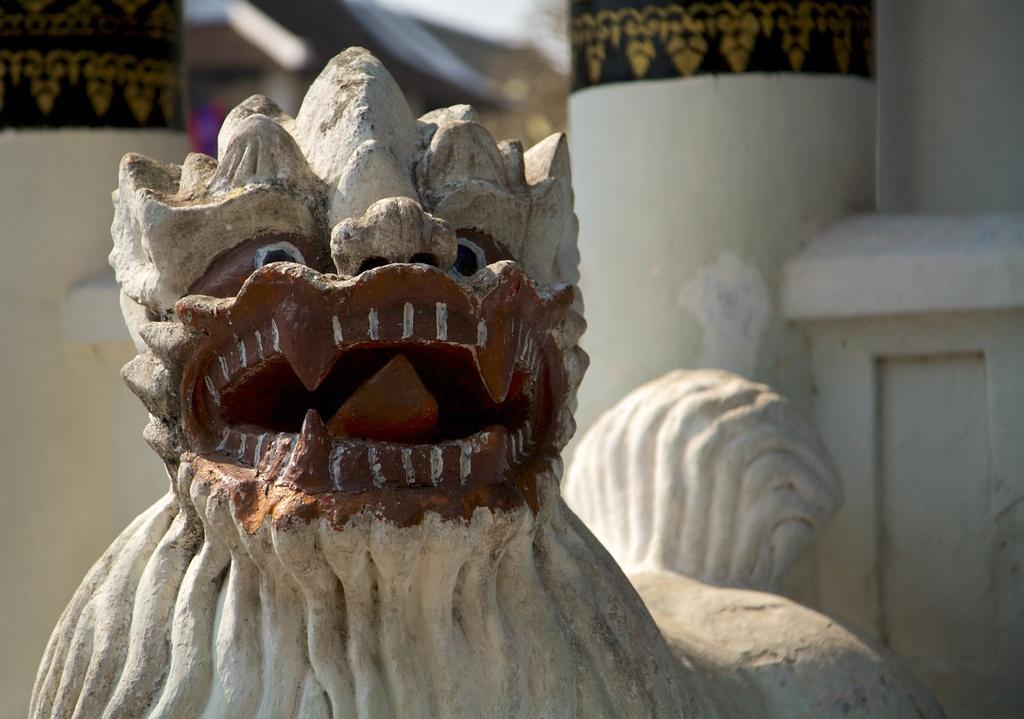Can you describe this image briefly? In the center of the image there is a sculpture. In the background we can see a wall. 